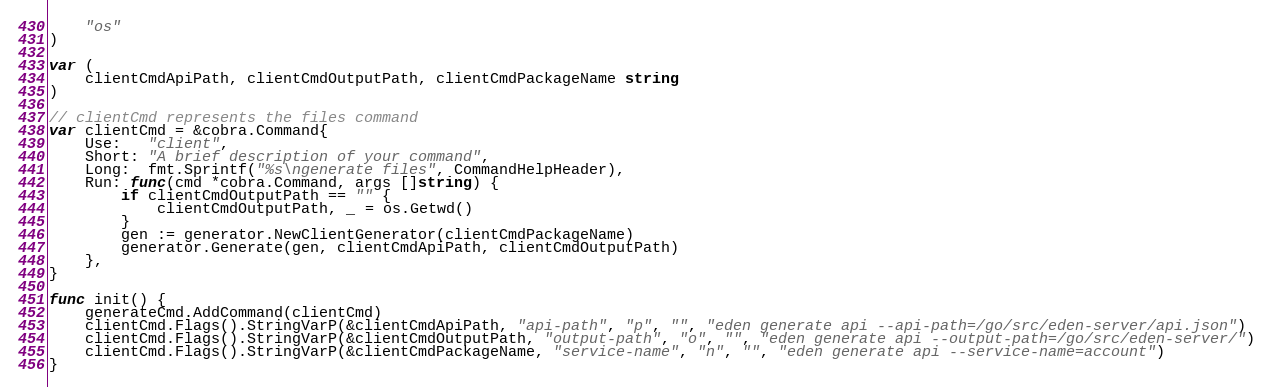Convert code to text. <code><loc_0><loc_0><loc_500><loc_500><_Go_>	"os"
)

var (
	clientCmdApiPath, clientCmdOutputPath, clientCmdPackageName string
)

// clientCmd represents the files command
var clientCmd = &cobra.Command{
	Use:   "client",
	Short: "A brief description of your command",
	Long:  fmt.Sprintf("%s\ngenerate files", CommandHelpHeader),
	Run: func(cmd *cobra.Command, args []string) {
		if clientCmdOutputPath == "" {
			clientCmdOutputPath, _ = os.Getwd()
		}
		gen := generator.NewClientGenerator(clientCmdPackageName)
		generator.Generate(gen, clientCmdApiPath, clientCmdOutputPath)
	},
}

func init() {
	generateCmd.AddCommand(clientCmd)
	clientCmd.Flags().StringVarP(&clientCmdApiPath, "api-path", "p", "", "eden generate api --api-path=/go/src/eden-server/api.json")
	clientCmd.Flags().StringVarP(&clientCmdOutputPath, "output-path", "o", "", "eden generate api --output-path=/go/src/eden-server/")
	clientCmd.Flags().StringVarP(&clientCmdPackageName, "service-name", "n", "", "eden generate api --service-name=account")
}
</code> 